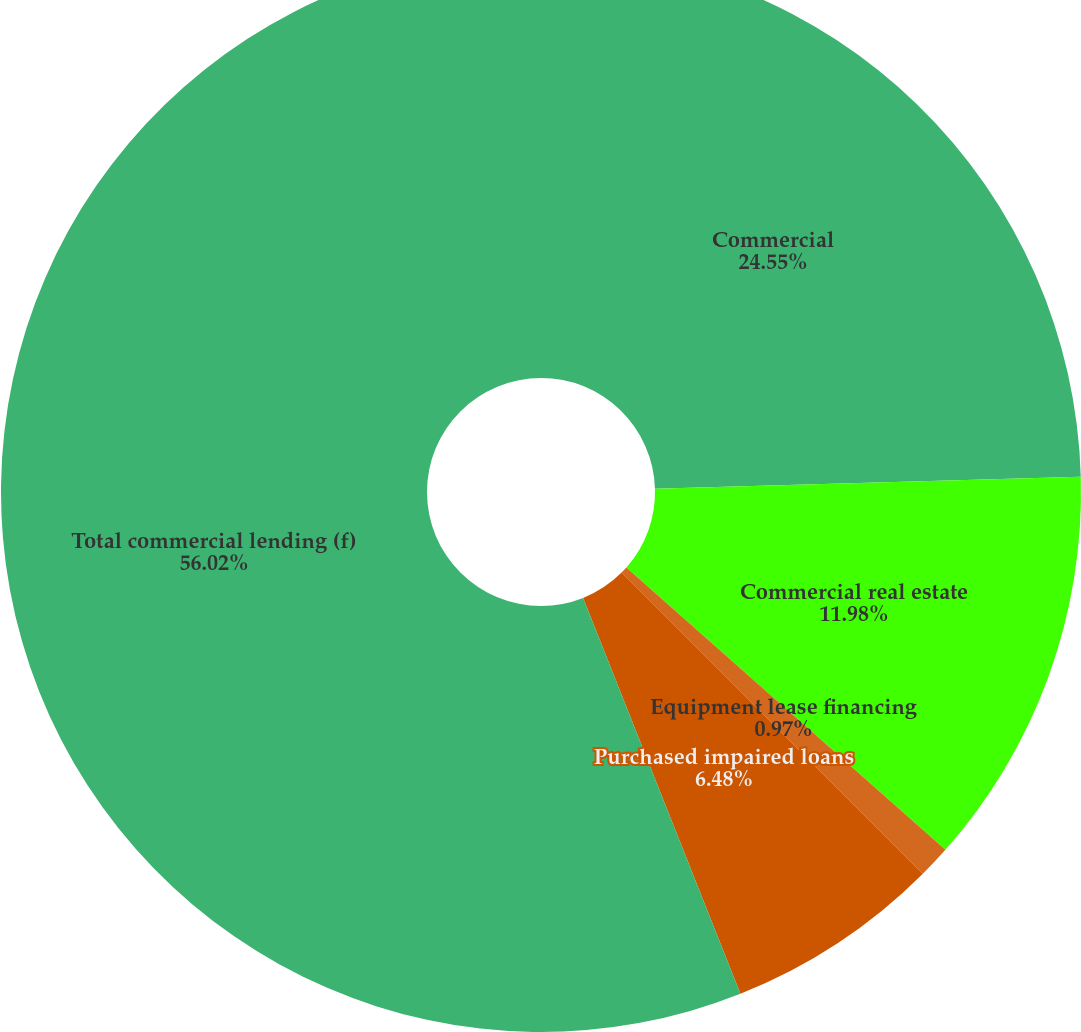<chart> <loc_0><loc_0><loc_500><loc_500><pie_chart><fcel>Commercial<fcel>Commercial real estate<fcel>Equipment lease financing<fcel>Purchased impaired loans<fcel>Total commercial lending (f)<nl><fcel>24.55%<fcel>11.98%<fcel>0.97%<fcel>6.48%<fcel>56.02%<nl></chart> 